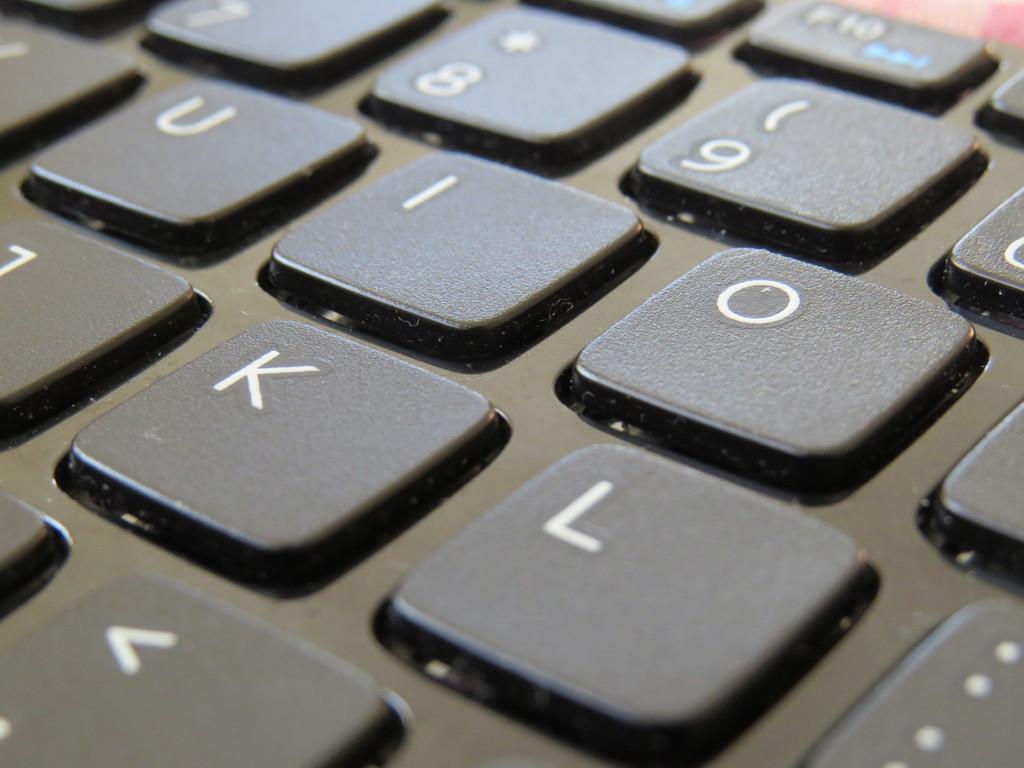In one or two sentences, can you explain what this image depicts? Picture of a keyboard. Here we can see alphabets and number keys. 